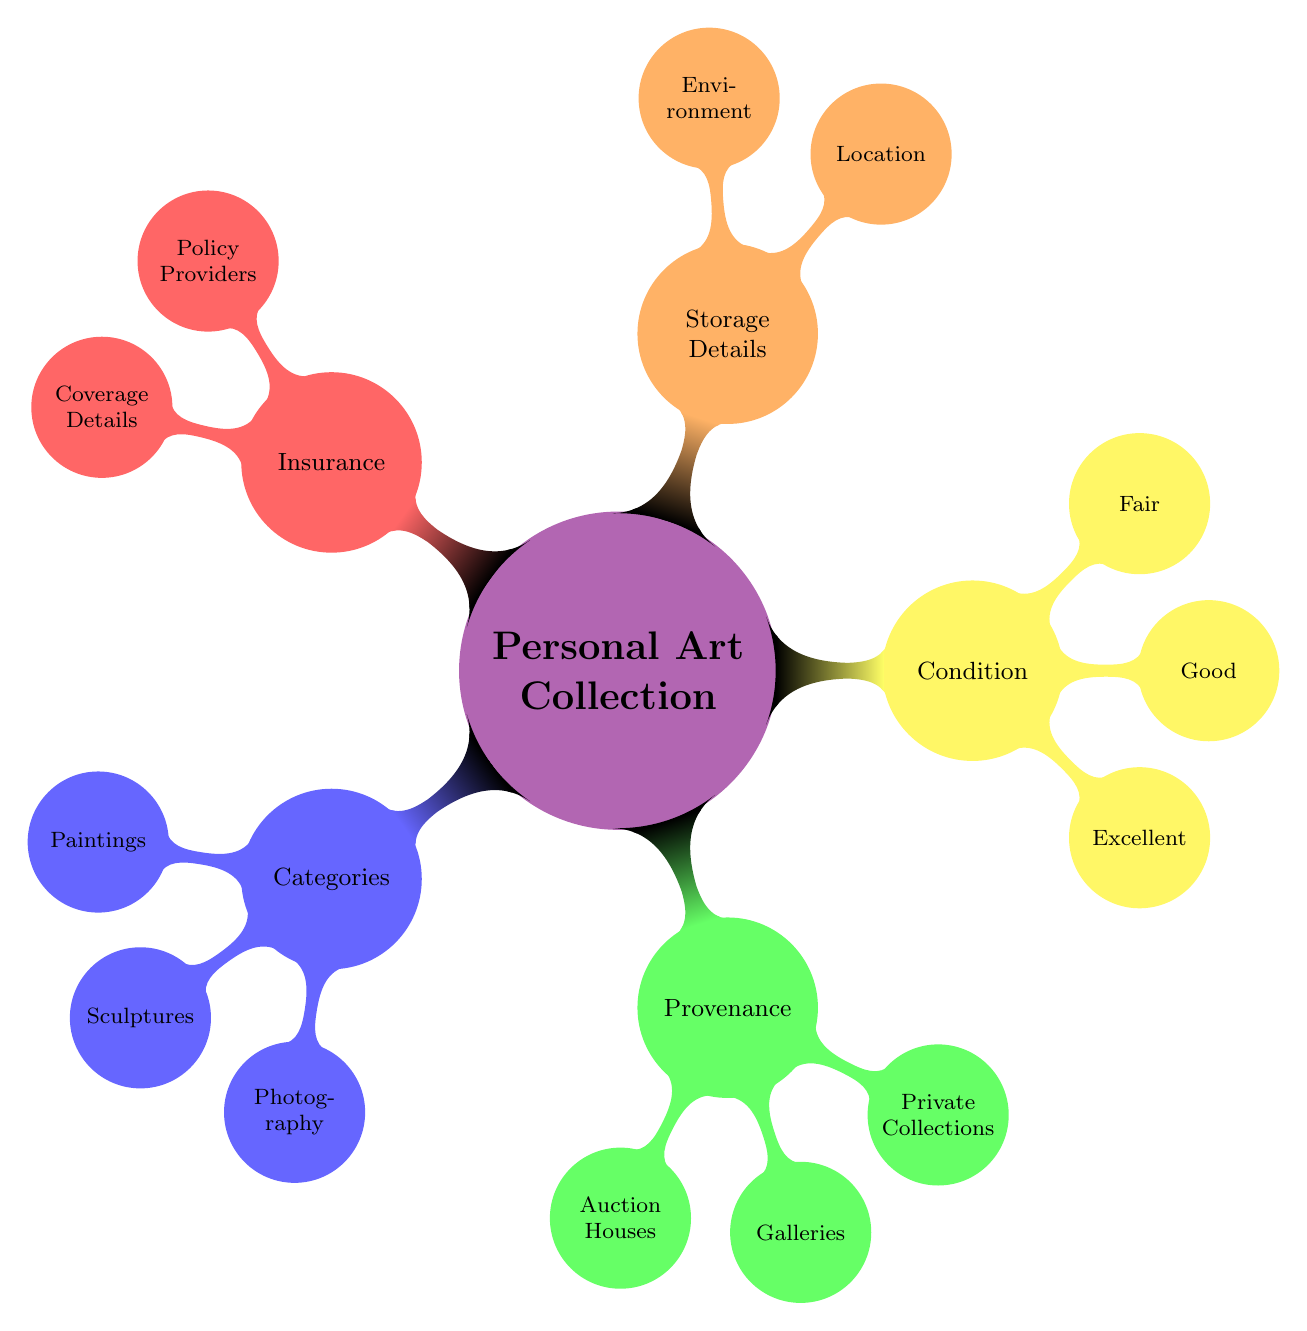What are the three main categories in the Personal Art Collection? The diagram lists three main categories expanding from the central node: Categories, Provenance, and Condition. These nodes are the first level of sub-nodes branching from the main concept.
Answer: Categories, Provenance, Condition How many types of sculptures are listed? Under the Sculptures category, there are two types specified: Classical and Modern. This count is taken from the immediate children of the Sculptures node.
Answer: 2 Which auction house is named in the Provenance section? The diagram includes two auction houses under Provenance, specifically naming Sotheby's. This information can be confirmed by looking at the child nodes of the Provenance section.
Answer: Sotheby's What types of environments are specified for the Storage Details? The Storage Details node has sub-nodes that list Temperature Controlled, Humidity Controlled, and Secure Display as types of environments for storing artworks. This information is derived from the child nodes of the Storage Details section.
Answer: Temperature Controlled, Humidity Controlled, Secure Display Which condition category mentions "Regular inspection"? The condition categorized as Excellent mentions "Regular inspection" as part of the information under it. This can be verified by tracing the path from Condition to Excellent through the sub-nodes.
Answer: Excellent What is the color of the node representing the “Photography” category? The Photography category node is colored in blue, following the color code assigned to the Categories level in the diagram.
Answer: Blue How many types are under the Condition category? There are three types listed under the Condition category: Excellent, Good, and Fair. This total is determined by counting the direct child nodes under the Condition node.
Answer: 3 What are the private collections mentioned in Provenance? The Provenance node lists two private collections: J. Paul Getty Museum and The Broad. These names are found in the relevant child nodes of the Provenance section.
Answer: J. Paul Getty Museum, The Broad Which provider is part of the Insurance node? Among the listed insurance Policy Providers, AXA Art Insurance is specified as one of the options. This is confirmed by checking the sub-nodes under the Insurance category.
Answer: AXA Art Insurance What two types of Paintings are shown in the diagram? The diagram distinguishes two types of Paintings: Impressionism and Post-Impressionism. Both are represented as sub-nodes branching from the main Categories node under Paintings.
Answer: Impressionism, Post-Impressionism 